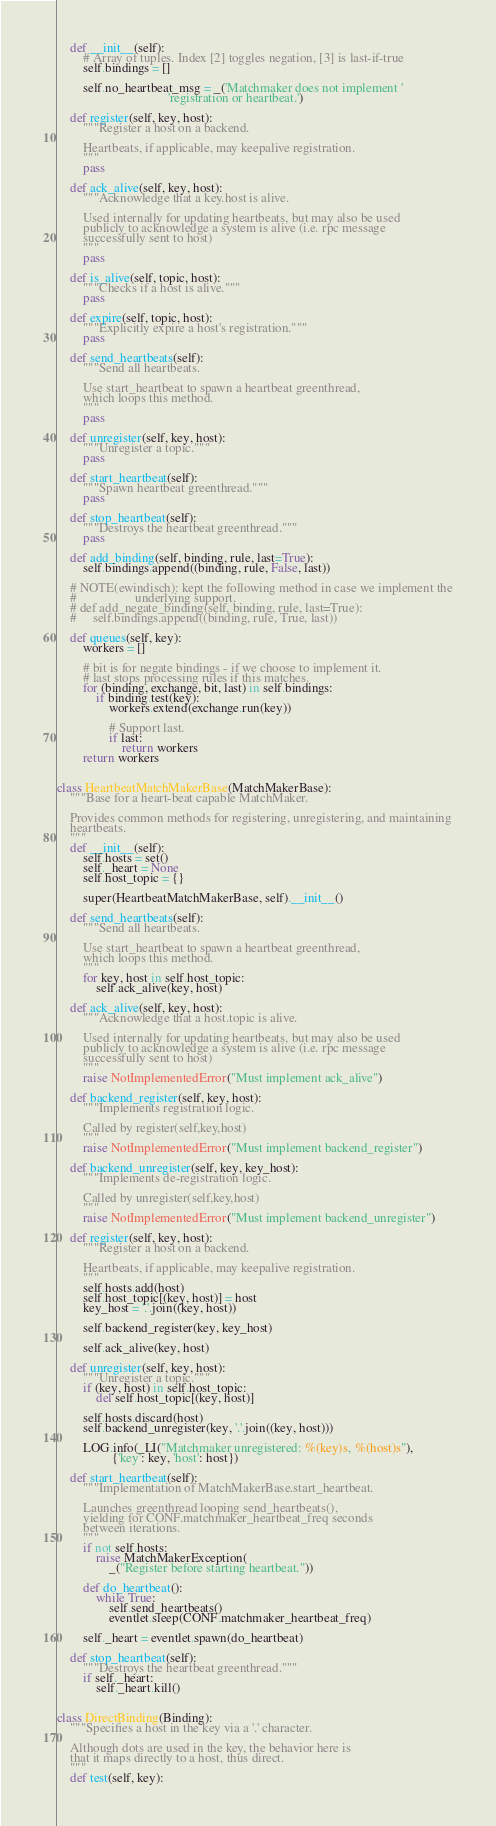<code> <loc_0><loc_0><loc_500><loc_500><_Python_>    def __init__(self):
        # Array of tuples. Index [2] toggles negation, [3] is last-if-true
        self.bindings = []

        self.no_heartbeat_msg = _('Matchmaker does not implement '
                                  'registration or heartbeat.')

    def register(self, key, host):
        """Register a host on a backend.

        Heartbeats, if applicable, may keepalive registration.
        """
        pass

    def ack_alive(self, key, host):
        """Acknowledge that a key.host is alive.

        Used internally for updating heartbeats, but may also be used
        publicly to acknowledge a system is alive (i.e. rpc message
        successfully sent to host)
        """
        pass

    def is_alive(self, topic, host):
        """Checks if a host is alive."""
        pass

    def expire(self, topic, host):
        """Explicitly expire a host's registration."""
        pass

    def send_heartbeats(self):
        """Send all heartbeats.

        Use start_heartbeat to spawn a heartbeat greenthread,
        which loops this method.
        """
        pass

    def unregister(self, key, host):
        """Unregister a topic."""
        pass

    def start_heartbeat(self):
        """Spawn heartbeat greenthread."""
        pass

    def stop_heartbeat(self):
        """Destroys the heartbeat greenthread."""
        pass

    def add_binding(self, binding, rule, last=True):
        self.bindings.append((binding, rule, False, last))

    # NOTE(ewindisch): kept the following method in case we implement the
    #                  underlying support.
    # def add_negate_binding(self, binding, rule, last=True):
    #     self.bindings.append((binding, rule, True, last))

    def queues(self, key):
        workers = []

        # bit is for negate bindings - if we choose to implement it.
        # last stops processing rules if this matches.
        for (binding, exchange, bit, last) in self.bindings:
            if binding.test(key):
                workers.extend(exchange.run(key))

                # Support last.
                if last:
                    return workers
        return workers


class HeartbeatMatchMakerBase(MatchMakerBase):
    """Base for a heart-beat capable MatchMaker.

    Provides common methods for registering, unregistering, and maintaining
    heartbeats.
    """
    def __init__(self):
        self.hosts = set()
        self._heart = None
        self.host_topic = {}

        super(HeartbeatMatchMakerBase, self).__init__()

    def send_heartbeats(self):
        """Send all heartbeats.

        Use start_heartbeat to spawn a heartbeat greenthread,
        which loops this method.
        """
        for key, host in self.host_topic:
            self.ack_alive(key, host)

    def ack_alive(self, key, host):
        """Acknowledge that a host.topic is alive.

        Used internally for updating heartbeats, but may also be used
        publicly to acknowledge a system is alive (i.e. rpc message
        successfully sent to host)
        """
        raise NotImplementedError("Must implement ack_alive")

    def backend_register(self, key, host):
        """Implements registration logic.

        Called by register(self,key,host)
        """
        raise NotImplementedError("Must implement backend_register")

    def backend_unregister(self, key, key_host):
        """Implements de-registration logic.

        Called by unregister(self,key,host)
        """
        raise NotImplementedError("Must implement backend_unregister")

    def register(self, key, host):
        """Register a host on a backend.

        Heartbeats, if applicable, may keepalive registration.
        """
        self.hosts.add(host)
        self.host_topic[(key, host)] = host
        key_host = '.'.join((key, host))

        self.backend_register(key, key_host)

        self.ack_alive(key, host)

    def unregister(self, key, host):
        """Unregister a topic."""
        if (key, host) in self.host_topic:
            del self.host_topic[(key, host)]

        self.hosts.discard(host)
        self.backend_unregister(key, '.'.join((key, host)))

        LOG.info(_LI("Matchmaker unregistered: %(key)s, %(host)s"),
                 {'key': key, 'host': host})

    def start_heartbeat(self):
        """Implementation of MatchMakerBase.start_heartbeat.

        Launches greenthread looping send_heartbeats(),
        yielding for CONF.matchmaker_heartbeat_freq seconds
        between iterations.
        """
        if not self.hosts:
            raise MatchMakerException(
                _("Register before starting heartbeat."))

        def do_heartbeat():
            while True:
                self.send_heartbeats()
                eventlet.sleep(CONF.matchmaker_heartbeat_freq)

        self._heart = eventlet.spawn(do_heartbeat)

    def stop_heartbeat(self):
        """Destroys the heartbeat greenthread."""
        if self._heart:
            self._heart.kill()


class DirectBinding(Binding):
    """Specifies a host in the key via a '.' character.

    Although dots are used in the key, the behavior here is
    that it maps directly to a host, thus direct.
    """
    def test(self, key):</code> 